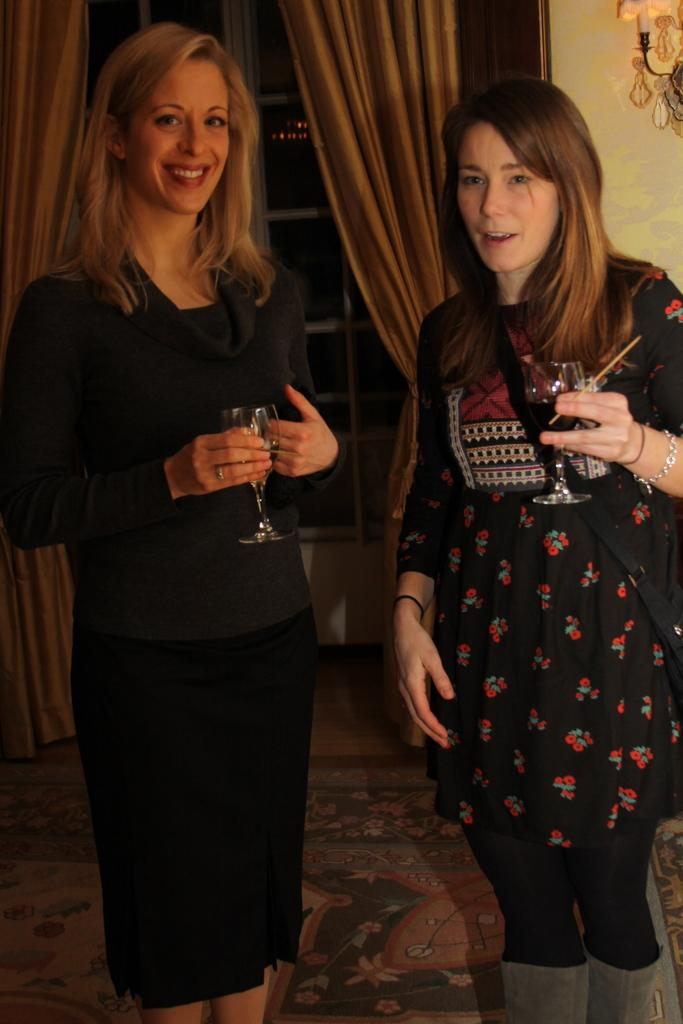How many women are in the image? There are 2 women in the image. What are the women doing in the image? The women are standing and holding a glass. What can be seen in the background of the image? There is a window with curtains in the image. What color are the dresses worn by the women? Both women are wearing black dresses. What type of quince is being used for the arithmetic in the image? There is no quince or arithmetic present in the image. What reward is being given to the woman for completing the task in the image? There is no task or reward depicted in the image. 